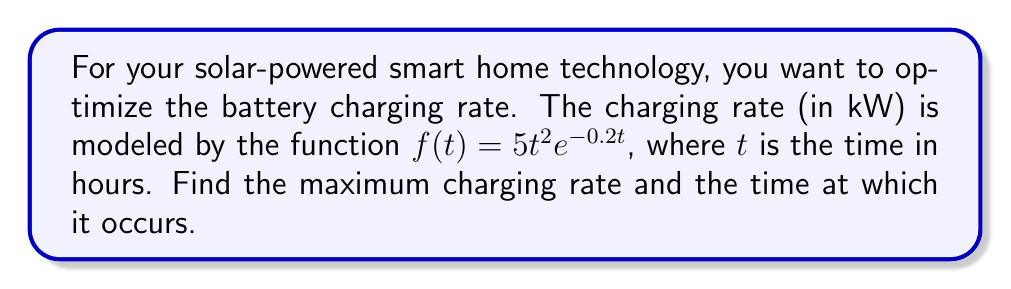What is the answer to this math problem? To find the maximum charging rate and the time at which it occurs, we need to find the critical points of the function $f(t) = 5t^2e^{-0.2t}$ and evaluate them.

Step 1: Find the derivative of $f(t)$.
Using the product rule and chain rule:
$$f'(t) = 5(2te^{-0.2t} + t^2(-0.2)e^{-0.2t})$$
$$f'(t) = 5e^{-0.2t}(2t - 0.2t^2)$$
$$f'(t) = 10te^{-0.2t} - t^2e^{-0.2t}$$

Step 2: Set $f'(t) = 0$ and solve for $t$.
$$10te^{-0.2t} - t^2e^{-0.2t} = 0$$
$$te^{-0.2t}(10 - t) = 0$$

For this to be true, either $t = 0$ or $10 - t = 0$. Since $t = 0$ results in $f(0) = 0$, which is not the maximum, we solve:
$$10 - t = 0$$
$$t = 10$$

Step 3: Verify this is a maximum by checking the second derivative or endpoints.
The function approaches 0 as $t$ approaches infinity, and $f(0) = 0$, so $t = 10$ must be a maximum.

Step 4: Calculate the maximum charging rate.
$$f(10) = 5(10)^2e^{-0.2(10)}$$
$$f(10) = 500e^{-2}$$
$$f(10) \approx 67.67 \text{ kW}$$

Therefore, the maximum charging rate is approximately 67.67 kW and occurs at t = 10 hours.
Answer: Maximum charging rate: 67.67 kW at t = 10 hours 